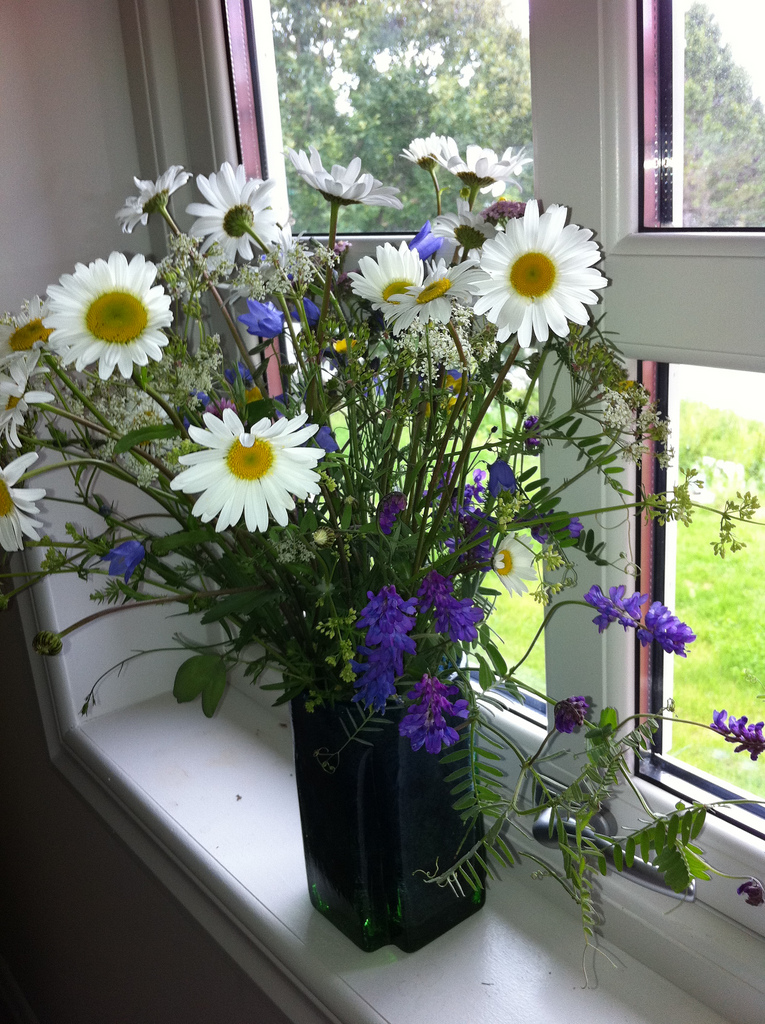Does the image convey a particular season? If so, which one and why? Yes, the image conveys a spring or early summer season. This is indicated by the blooming wildflowers and the lush, green lawn visible through the window, which are characteristic of these seasons. What kind of environment do you imagine this windowed space is part of? This windowed space seems to be part of a cozy, country-style home or cottage. The view of the greenery outside suggests it is set in a rural or suburban area. The simple yet charming decor of the flowers on the windowsill adds to a relaxed and welcoming ambiance, ideal for a home that appreciates nature's beauty. Let's imagine an event took place here. What kind of event would it be? This setting could be perfect for a small, intimate gathering such as a tea party or a book club meeting. Guests might sit by the window enjoying the view, engaging in light conversation, and sipping on tea or coffee. The bouquet adds a festive touch, enhancing the atmosphere with its fresh scent and vibrant colors. Imagine if the flowers started to tell the stories of the people who have lived in this house. What might they say? If the flowers could speak, they might tell stories of family dinners filled with laughter, quiet afternoons with a book in hand by the window, and mornings where the first light of day filtered through, casting a glow on cherished moments. They'd recall the various faces that leaned in to inhale their scent, the melodic hum of content conversations, and the countless moments of peace and reflection. Each petal and stem would hold a memory, from the cheerful gatherings to the silent appreciations of their simple beauty that added to the home's charm. What would a short story inspired by this image be like? Once upon a time, in a quaint cottage nestled between rolling hills, there lived an elderly woman named Eleanor. She spent her mornings tending to her wildflower garden, which was the pride of her home. One day, she noticed that the flowers she had arranged in a vase on her windowsill had started to bloom more vibrantly than ever. This tiny miracle filled her with such joy that she decided to host a tea party for her neighbors, bringing together a community that had drifted apart over the years. The flowers, with their newfound life, seemed to nod in approval, as if they, too, were grateful for the laughter and stories that now filled the air. From that day on, Eleanor's home became a haven for friendship and warmth, all sparked by a simple bouquet of wildflowers. 